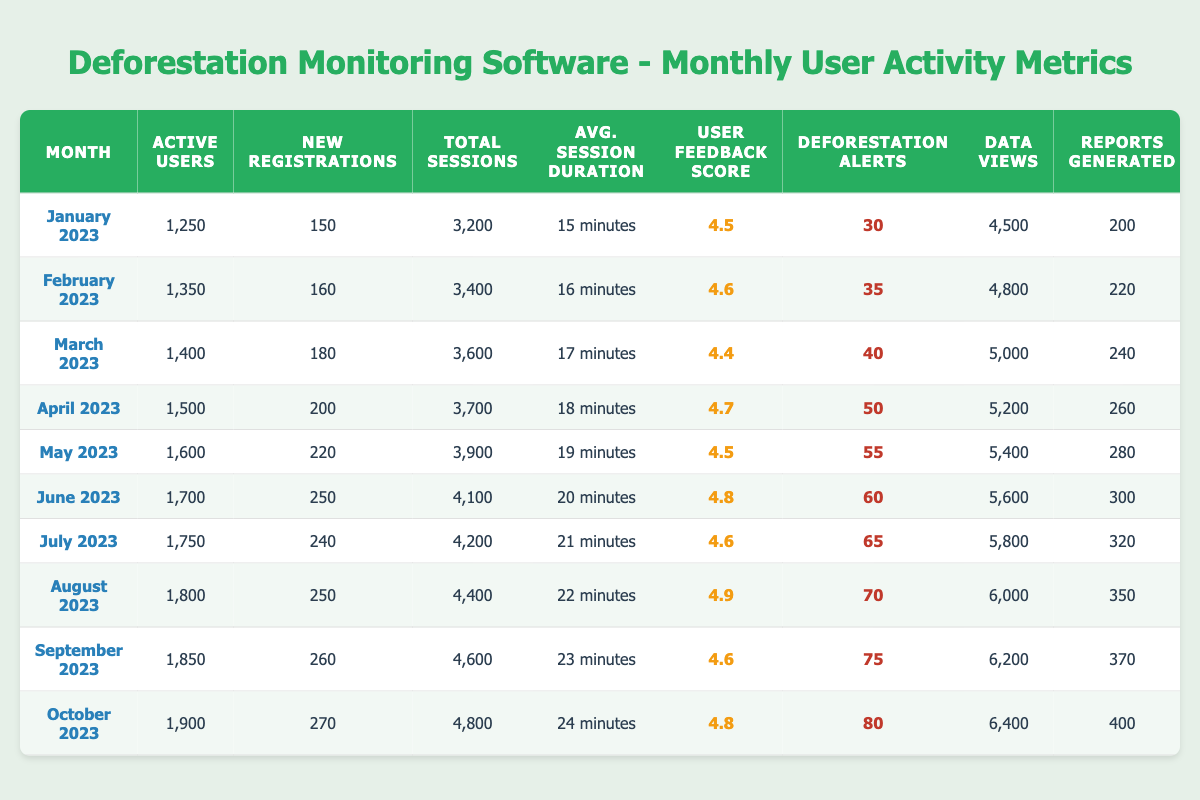What was the average user feedback score from January to October 2023? To find the average, we sum the feedback scores from each month: (4.5 + 4.6 + 4.4 + 4.7 + 4.5 + 4.8 + 4.6 + 4.9 + 4.6 + 4.8) = 46.5. Then, divide by the number of months (10), which gives us 46.5 / 10 = 4.65.
Answer: 4.65 How many total new registrations were made from January to October 2023? We need to sum the new registrations for each month: (150 + 160 + 180 + 200 + 220 + 250 + 240 + 250 + 260 + 270) = 2260.
Answer: 2260 Did the number of active users increase every month from January to October 2023? By examining the active users for each month, we see that the numbers consistently rise: 1250, 1350, 1400, 1500, 1600, 1700, 1750, 1800, 1850, and 1900. Thus, there are increases every month.
Answer: Yes In which month was the maximum number of deforestation alerts triggered? The maximum deforestation alerts are found in October 2023, which had 80 alerts triggered.
Answer: October 2023 What is the total number of reports generated from June to October 2023? We sum the reports generated from June to October: (300 + 320 + 350 + 370 + 400) = 1740.
Answer: 1740 Which month had the longest average session duration, and what was that duration? By checking the average session durations for each month, we see that October 2023 had the longest duration of 24 minutes.
Answer: October 2023, 24 minutes What is the growth in active users from January to October 2023? The number of active users in January was 1250, and in October it was 1900. Therefore, the growth is 1900 - 1250 = 650 active users.
Answer: 650 How many deforestation alerts were triggered in the first half of 2023 (January to June)? Summing the alerts from January to June: (30 + 35 + 40 + 50 + 55 + 60) = 270 alerts triggered.
Answer: 270 Calculate the average number of total sessions per month for the entire data set. Summing total sessions gives 3200 + 3400 + 3600 + 3700 + 3900 + 4100 + 4200 + 4400 + 4600 + 4800 = 39900. Dividing by 10 (months), we get 39900 / 10 = 3990.
Answer: 3990 What percentage increase in data views occurred from January to October 2023? Data views in January were 4500, and in October they were 6400. The increase is 6400 - 4500 = 1900. The percentage increase is (1900 / 4500) * 100 = 42.22%.
Answer: 42.22% 